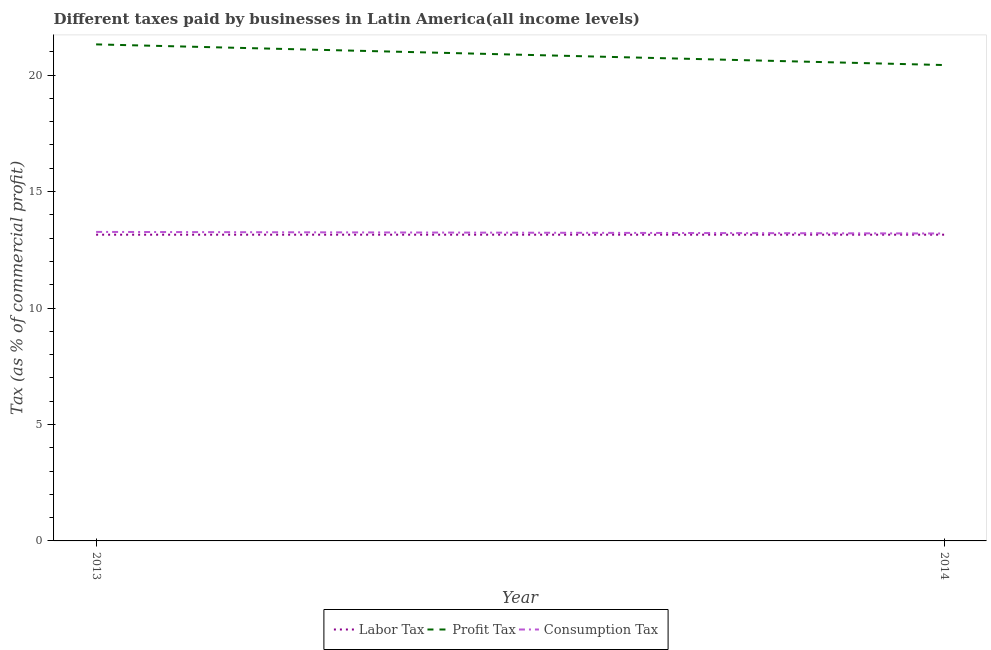Does the line corresponding to percentage of profit tax intersect with the line corresponding to percentage of labor tax?
Keep it short and to the point. No. Is the number of lines equal to the number of legend labels?
Provide a short and direct response. Yes. Across all years, what is the maximum percentage of consumption tax?
Offer a terse response. 13.27. Across all years, what is the minimum percentage of consumption tax?
Offer a very short reply. 13.2. In which year was the percentage of labor tax maximum?
Keep it short and to the point. 2013. What is the total percentage of labor tax in the graph?
Make the answer very short. 26.3. What is the difference between the percentage of labor tax in 2013 and that in 2014?
Your answer should be compact. 0. What is the difference between the percentage of consumption tax in 2013 and the percentage of profit tax in 2014?
Offer a very short reply. -7.16. What is the average percentage of consumption tax per year?
Provide a short and direct response. 13.23. In the year 2013, what is the difference between the percentage of consumption tax and percentage of labor tax?
Your response must be concise. 0.12. What is the ratio of the percentage of consumption tax in 2013 to that in 2014?
Provide a succinct answer. 1.01. In how many years, is the percentage of profit tax greater than the average percentage of profit tax taken over all years?
Ensure brevity in your answer.  1. Does the percentage of profit tax monotonically increase over the years?
Offer a very short reply. No. Is the percentage of profit tax strictly greater than the percentage of labor tax over the years?
Offer a terse response. Yes. Is the percentage of profit tax strictly less than the percentage of labor tax over the years?
Keep it short and to the point. No. How many lines are there?
Keep it short and to the point. 3. What is the difference between two consecutive major ticks on the Y-axis?
Provide a succinct answer. 5. Are the values on the major ticks of Y-axis written in scientific E-notation?
Ensure brevity in your answer.  No. How are the legend labels stacked?
Provide a succinct answer. Horizontal. What is the title of the graph?
Your answer should be very brief. Different taxes paid by businesses in Latin America(all income levels). Does "Total employers" appear as one of the legend labels in the graph?
Your response must be concise. No. What is the label or title of the X-axis?
Offer a very short reply. Year. What is the label or title of the Y-axis?
Offer a terse response. Tax (as % of commercial profit). What is the Tax (as % of commercial profit) of Labor Tax in 2013?
Your response must be concise. 13.15. What is the Tax (as % of commercial profit) of Profit Tax in 2013?
Provide a succinct answer. 21.32. What is the Tax (as % of commercial profit) in Consumption Tax in 2013?
Your response must be concise. 13.27. What is the Tax (as % of commercial profit) of Labor Tax in 2014?
Your response must be concise. 13.15. What is the Tax (as % of commercial profit) of Profit Tax in 2014?
Your answer should be compact. 20.43. What is the Tax (as % of commercial profit) of Consumption Tax in 2014?
Offer a very short reply. 13.2. Across all years, what is the maximum Tax (as % of commercial profit) of Labor Tax?
Provide a succinct answer. 13.15. Across all years, what is the maximum Tax (as % of commercial profit) in Profit Tax?
Make the answer very short. 21.32. Across all years, what is the maximum Tax (as % of commercial profit) of Consumption Tax?
Keep it short and to the point. 13.27. Across all years, what is the minimum Tax (as % of commercial profit) of Labor Tax?
Offer a very short reply. 13.15. Across all years, what is the minimum Tax (as % of commercial profit) in Profit Tax?
Provide a succinct answer. 20.43. Across all years, what is the minimum Tax (as % of commercial profit) in Consumption Tax?
Your answer should be very brief. 13.2. What is the total Tax (as % of commercial profit) in Labor Tax in the graph?
Your answer should be compact. 26.3. What is the total Tax (as % of commercial profit) of Profit Tax in the graph?
Make the answer very short. 41.75. What is the total Tax (as % of commercial profit) in Consumption Tax in the graph?
Give a very brief answer. 26.47. What is the difference between the Tax (as % of commercial profit) in Profit Tax in 2013 and that in 2014?
Give a very brief answer. 0.89. What is the difference between the Tax (as % of commercial profit) in Consumption Tax in 2013 and that in 2014?
Your answer should be compact. 0.07. What is the difference between the Tax (as % of commercial profit) of Labor Tax in 2013 and the Tax (as % of commercial profit) of Profit Tax in 2014?
Provide a succinct answer. -7.28. What is the difference between the Tax (as % of commercial profit) in Labor Tax in 2013 and the Tax (as % of commercial profit) in Consumption Tax in 2014?
Ensure brevity in your answer.  -0.05. What is the difference between the Tax (as % of commercial profit) in Profit Tax in 2013 and the Tax (as % of commercial profit) in Consumption Tax in 2014?
Offer a terse response. 8.12. What is the average Tax (as % of commercial profit) of Labor Tax per year?
Keep it short and to the point. 13.15. What is the average Tax (as % of commercial profit) of Profit Tax per year?
Keep it short and to the point. 20.88. What is the average Tax (as % of commercial profit) of Consumption Tax per year?
Provide a succinct answer. 13.23. In the year 2013, what is the difference between the Tax (as % of commercial profit) in Labor Tax and Tax (as % of commercial profit) in Profit Tax?
Your answer should be compact. -8.17. In the year 2013, what is the difference between the Tax (as % of commercial profit) of Labor Tax and Tax (as % of commercial profit) of Consumption Tax?
Provide a succinct answer. -0.12. In the year 2013, what is the difference between the Tax (as % of commercial profit) of Profit Tax and Tax (as % of commercial profit) of Consumption Tax?
Give a very brief answer. 8.05. In the year 2014, what is the difference between the Tax (as % of commercial profit) in Labor Tax and Tax (as % of commercial profit) in Profit Tax?
Provide a succinct answer. -7.28. In the year 2014, what is the difference between the Tax (as % of commercial profit) in Labor Tax and Tax (as % of commercial profit) in Consumption Tax?
Provide a succinct answer. -0.05. In the year 2014, what is the difference between the Tax (as % of commercial profit) in Profit Tax and Tax (as % of commercial profit) in Consumption Tax?
Ensure brevity in your answer.  7.23. What is the ratio of the Tax (as % of commercial profit) in Profit Tax in 2013 to that in 2014?
Offer a terse response. 1.04. What is the difference between the highest and the second highest Tax (as % of commercial profit) of Labor Tax?
Ensure brevity in your answer.  0. What is the difference between the highest and the second highest Tax (as % of commercial profit) in Profit Tax?
Your answer should be very brief. 0.89. What is the difference between the highest and the second highest Tax (as % of commercial profit) in Consumption Tax?
Your answer should be very brief. 0.07. What is the difference between the highest and the lowest Tax (as % of commercial profit) in Profit Tax?
Your answer should be compact. 0.89. What is the difference between the highest and the lowest Tax (as % of commercial profit) of Consumption Tax?
Your answer should be compact. 0.07. 